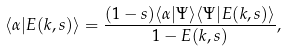Convert formula to latex. <formula><loc_0><loc_0><loc_500><loc_500>\langle \alpha | E ( k , s ) \rangle = \frac { ( 1 - s ) \langle \alpha | \Psi \rangle \langle \Psi | E ( k , s ) \rangle } { 1 - E ( k , s ) } ,</formula> 